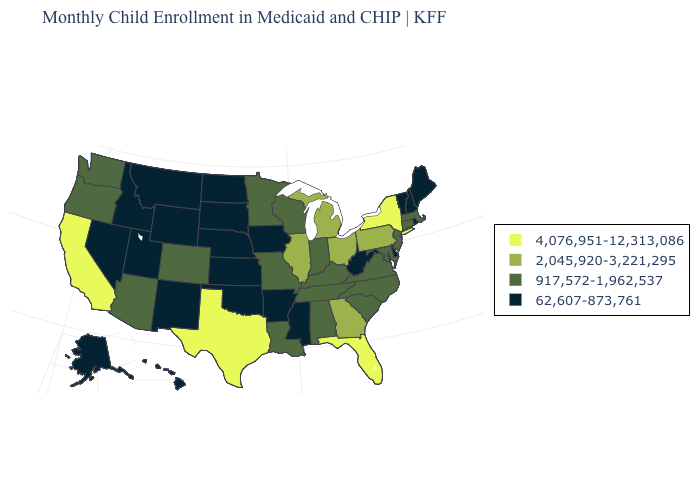Name the states that have a value in the range 62,607-873,761?
Quick response, please. Alaska, Arkansas, Delaware, Hawaii, Idaho, Iowa, Kansas, Maine, Mississippi, Montana, Nebraska, Nevada, New Hampshire, New Mexico, North Dakota, Oklahoma, Rhode Island, South Dakota, Utah, Vermont, West Virginia, Wyoming. What is the value of Idaho?
Give a very brief answer. 62,607-873,761. Which states hav the highest value in the South?
Concise answer only. Florida, Texas. Does the first symbol in the legend represent the smallest category?
Answer briefly. No. Does Wisconsin have a higher value than Illinois?
Be succinct. No. Does the map have missing data?
Keep it brief. No. Does the first symbol in the legend represent the smallest category?
Concise answer only. No. Does the map have missing data?
Quick response, please. No. Which states hav the highest value in the Northeast?
Give a very brief answer. New York. Does the first symbol in the legend represent the smallest category?
Write a very short answer. No. Does Alaska have a lower value than South Dakota?
Keep it brief. No. What is the lowest value in the West?
Answer briefly. 62,607-873,761. What is the highest value in the USA?
Concise answer only. 4,076,951-12,313,086. Name the states that have a value in the range 4,076,951-12,313,086?
Give a very brief answer. California, Florida, New York, Texas. 